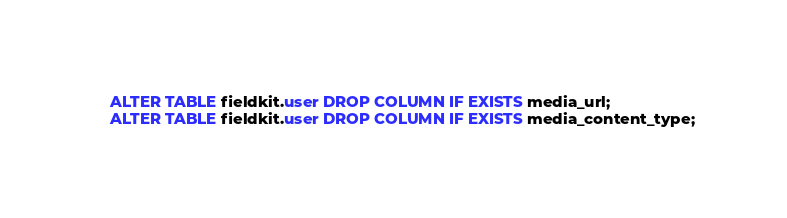<code> <loc_0><loc_0><loc_500><loc_500><_SQL_>ALTER TABLE fieldkit.user DROP COLUMN IF EXISTS media_url;
ALTER TABLE fieldkit.user DROP COLUMN IF EXISTS media_content_type;
</code> 